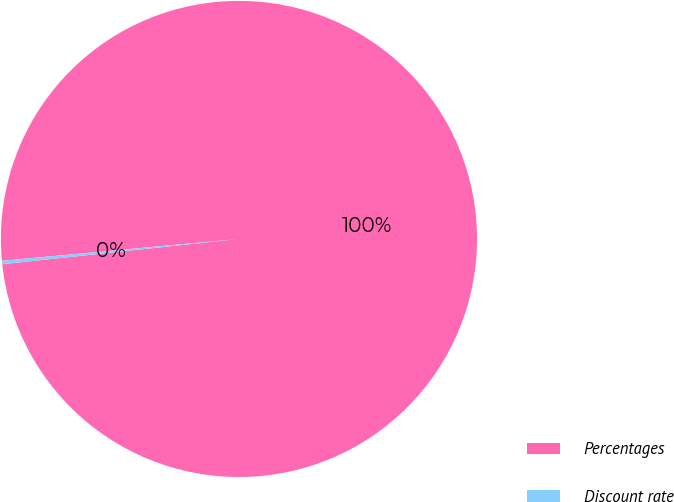<chart> <loc_0><loc_0><loc_500><loc_500><pie_chart><fcel>Percentages<fcel>Discount rate<nl><fcel>99.77%<fcel>0.23%<nl></chart> 